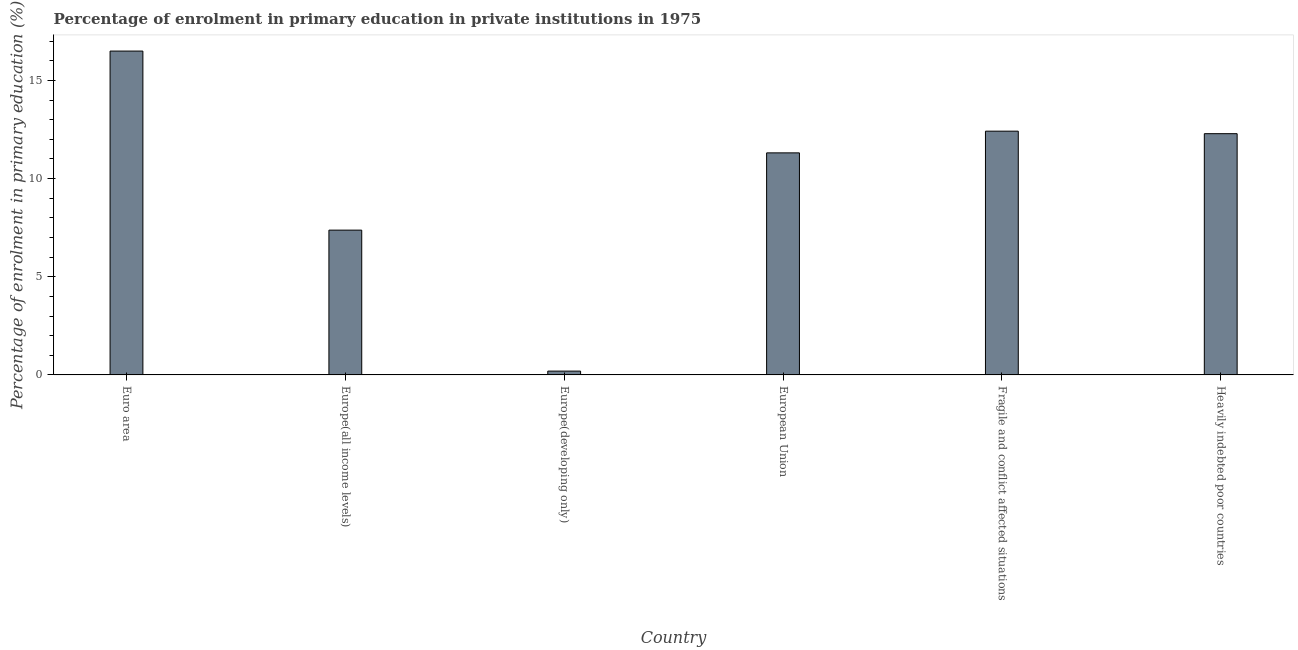Does the graph contain any zero values?
Your answer should be very brief. No. What is the title of the graph?
Ensure brevity in your answer.  Percentage of enrolment in primary education in private institutions in 1975. What is the label or title of the X-axis?
Make the answer very short. Country. What is the label or title of the Y-axis?
Provide a succinct answer. Percentage of enrolment in primary education (%). What is the enrolment percentage in primary education in Euro area?
Keep it short and to the point. 16.5. Across all countries, what is the maximum enrolment percentage in primary education?
Your answer should be compact. 16.5. Across all countries, what is the minimum enrolment percentage in primary education?
Provide a succinct answer. 0.19. In which country was the enrolment percentage in primary education maximum?
Your response must be concise. Euro area. In which country was the enrolment percentage in primary education minimum?
Your answer should be compact. Europe(developing only). What is the sum of the enrolment percentage in primary education?
Give a very brief answer. 60.08. What is the difference between the enrolment percentage in primary education in Europe(all income levels) and Fragile and conflict affected situations?
Ensure brevity in your answer.  -5.04. What is the average enrolment percentage in primary education per country?
Offer a very short reply. 10.01. What is the median enrolment percentage in primary education?
Provide a succinct answer. 11.8. In how many countries, is the enrolment percentage in primary education greater than 8 %?
Ensure brevity in your answer.  4. What is the ratio of the enrolment percentage in primary education in Euro area to that in Fragile and conflict affected situations?
Offer a very short reply. 1.33. Is the difference between the enrolment percentage in primary education in Europe(all income levels) and Fragile and conflict affected situations greater than the difference between any two countries?
Give a very brief answer. No. What is the difference between the highest and the second highest enrolment percentage in primary education?
Provide a short and direct response. 4.08. Is the sum of the enrolment percentage in primary education in Euro area and Europe(developing only) greater than the maximum enrolment percentage in primary education across all countries?
Provide a succinct answer. Yes. What is the difference between the highest and the lowest enrolment percentage in primary education?
Offer a very short reply. 16.3. In how many countries, is the enrolment percentage in primary education greater than the average enrolment percentage in primary education taken over all countries?
Provide a succinct answer. 4. Are all the bars in the graph horizontal?
Ensure brevity in your answer.  No. How many countries are there in the graph?
Give a very brief answer. 6. Are the values on the major ticks of Y-axis written in scientific E-notation?
Offer a terse response. No. What is the Percentage of enrolment in primary education (%) in Euro area?
Keep it short and to the point. 16.5. What is the Percentage of enrolment in primary education (%) of Europe(all income levels)?
Keep it short and to the point. 7.38. What is the Percentage of enrolment in primary education (%) in Europe(developing only)?
Provide a succinct answer. 0.19. What is the Percentage of enrolment in primary education (%) in European Union?
Make the answer very short. 11.31. What is the Percentage of enrolment in primary education (%) of Fragile and conflict affected situations?
Give a very brief answer. 12.42. What is the Percentage of enrolment in primary education (%) in Heavily indebted poor countries?
Give a very brief answer. 12.29. What is the difference between the Percentage of enrolment in primary education (%) in Euro area and Europe(all income levels)?
Your answer should be very brief. 9.12. What is the difference between the Percentage of enrolment in primary education (%) in Euro area and Europe(developing only)?
Offer a very short reply. 16.3. What is the difference between the Percentage of enrolment in primary education (%) in Euro area and European Union?
Your answer should be compact. 5.19. What is the difference between the Percentage of enrolment in primary education (%) in Euro area and Fragile and conflict affected situations?
Provide a short and direct response. 4.08. What is the difference between the Percentage of enrolment in primary education (%) in Euro area and Heavily indebted poor countries?
Offer a very short reply. 4.21. What is the difference between the Percentage of enrolment in primary education (%) in Europe(all income levels) and Europe(developing only)?
Offer a very short reply. 7.18. What is the difference between the Percentage of enrolment in primary education (%) in Europe(all income levels) and European Union?
Your answer should be very brief. -3.94. What is the difference between the Percentage of enrolment in primary education (%) in Europe(all income levels) and Fragile and conflict affected situations?
Offer a very short reply. -5.04. What is the difference between the Percentage of enrolment in primary education (%) in Europe(all income levels) and Heavily indebted poor countries?
Ensure brevity in your answer.  -4.91. What is the difference between the Percentage of enrolment in primary education (%) in Europe(developing only) and European Union?
Provide a succinct answer. -11.12. What is the difference between the Percentage of enrolment in primary education (%) in Europe(developing only) and Fragile and conflict affected situations?
Provide a succinct answer. -12.22. What is the difference between the Percentage of enrolment in primary education (%) in Europe(developing only) and Heavily indebted poor countries?
Keep it short and to the point. -12.1. What is the difference between the Percentage of enrolment in primary education (%) in European Union and Fragile and conflict affected situations?
Keep it short and to the point. -1.11. What is the difference between the Percentage of enrolment in primary education (%) in European Union and Heavily indebted poor countries?
Your answer should be very brief. -0.98. What is the difference between the Percentage of enrolment in primary education (%) in Fragile and conflict affected situations and Heavily indebted poor countries?
Your answer should be compact. 0.13. What is the ratio of the Percentage of enrolment in primary education (%) in Euro area to that in Europe(all income levels)?
Offer a very short reply. 2.24. What is the ratio of the Percentage of enrolment in primary education (%) in Euro area to that in Europe(developing only)?
Give a very brief answer. 85.08. What is the ratio of the Percentage of enrolment in primary education (%) in Euro area to that in European Union?
Your answer should be compact. 1.46. What is the ratio of the Percentage of enrolment in primary education (%) in Euro area to that in Fragile and conflict affected situations?
Your answer should be very brief. 1.33. What is the ratio of the Percentage of enrolment in primary education (%) in Euro area to that in Heavily indebted poor countries?
Give a very brief answer. 1.34. What is the ratio of the Percentage of enrolment in primary education (%) in Europe(all income levels) to that in Europe(developing only)?
Offer a very short reply. 38.04. What is the ratio of the Percentage of enrolment in primary education (%) in Europe(all income levels) to that in European Union?
Keep it short and to the point. 0.65. What is the ratio of the Percentage of enrolment in primary education (%) in Europe(all income levels) to that in Fragile and conflict affected situations?
Provide a succinct answer. 0.59. What is the ratio of the Percentage of enrolment in primary education (%) in Europe(developing only) to that in European Union?
Your response must be concise. 0.02. What is the ratio of the Percentage of enrolment in primary education (%) in Europe(developing only) to that in Fragile and conflict affected situations?
Keep it short and to the point. 0.02. What is the ratio of the Percentage of enrolment in primary education (%) in Europe(developing only) to that in Heavily indebted poor countries?
Provide a short and direct response. 0.02. What is the ratio of the Percentage of enrolment in primary education (%) in European Union to that in Fragile and conflict affected situations?
Keep it short and to the point. 0.91. What is the ratio of the Percentage of enrolment in primary education (%) in European Union to that in Heavily indebted poor countries?
Offer a very short reply. 0.92. What is the ratio of the Percentage of enrolment in primary education (%) in Fragile and conflict affected situations to that in Heavily indebted poor countries?
Your answer should be compact. 1.01. 